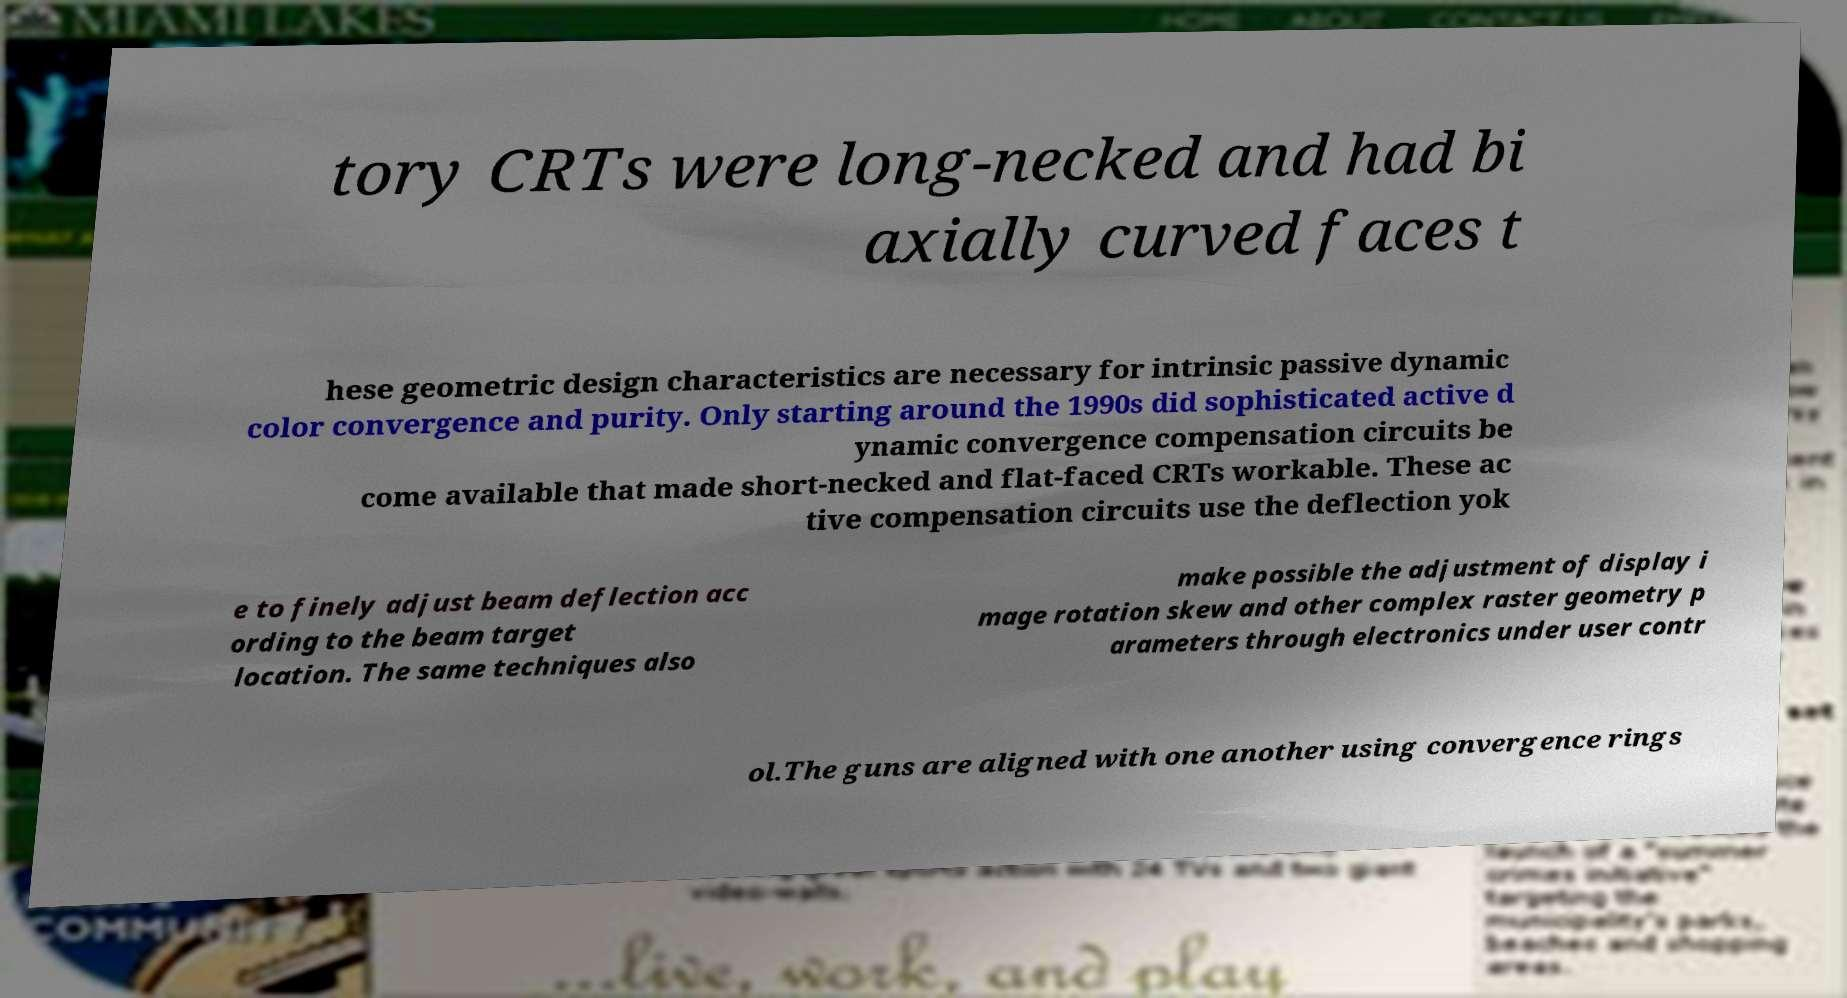Can you read and provide the text displayed in the image?This photo seems to have some interesting text. Can you extract and type it out for me? tory CRTs were long-necked and had bi axially curved faces t hese geometric design characteristics are necessary for intrinsic passive dynamic color convergence and purity. Only starting around the 1990s did sophisticated active d ynamic convergence compensation circuits be come available that made short-necked and flat-faced CRTs workable. These ac tive compensation circuits use the deflection yok e to finely adjust beam deflection acc ording to the beam target location. The same techniques also make possible the adjustment of display i mage rotation skew and other complex raster geometry p arameters through electronics under user contr ol.The guns are aligned with one another using convergence rings 